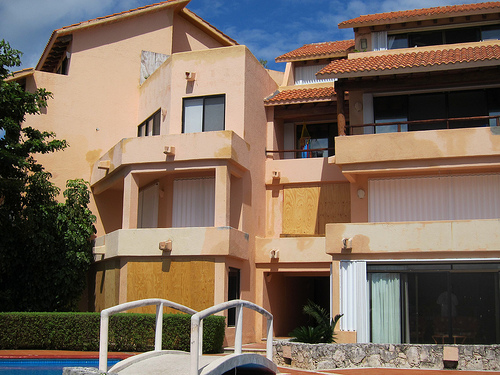<image>
Is there a bridge under the window? No. The bridge is not positioned under the window. The vertical relationship between these objects is different. 